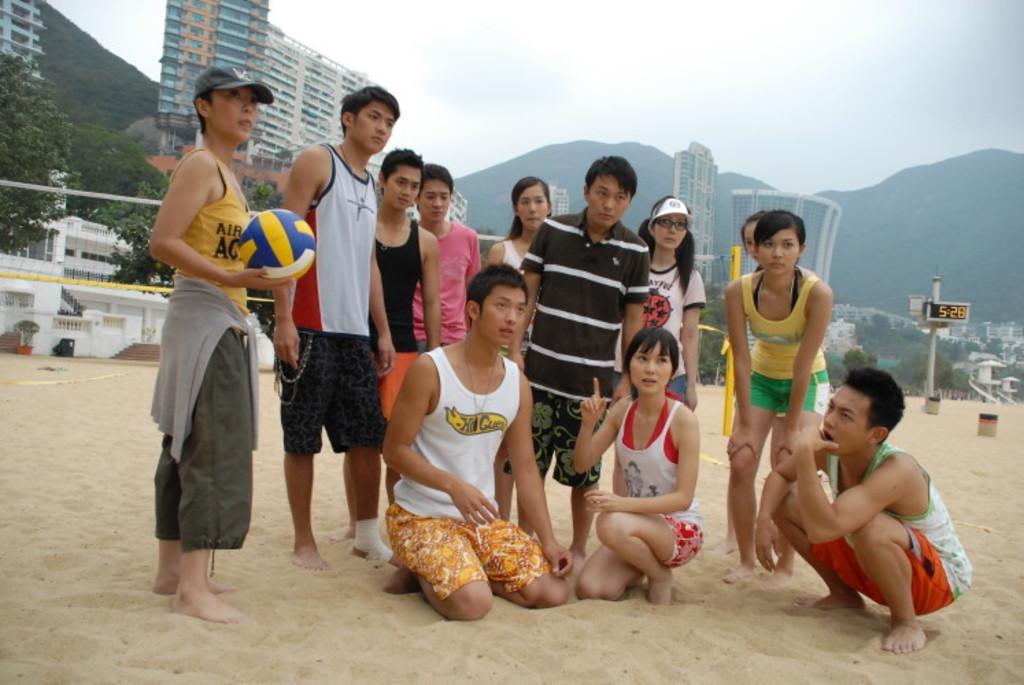Could you give a brief overview of what you see in this image? This picture shows few people standing and we see few of them seated on the knees and we see a woman holding a ball in her hand and couple of them wore caps to their heads and we see buildings and trees and a net and we see a cloudy sky and we see sand around. 